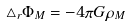Convert formula to latex. <formula><loc_0><loc_0><loc_500><loc_500>\triangle _ { r } \Phi _ { M } = - 4 \pi G \rho _ { M }</formula> 